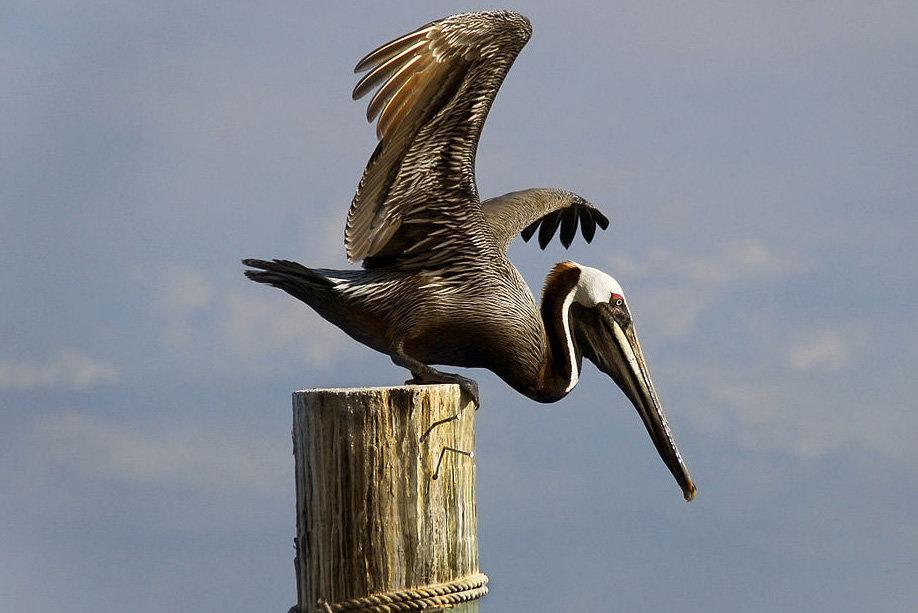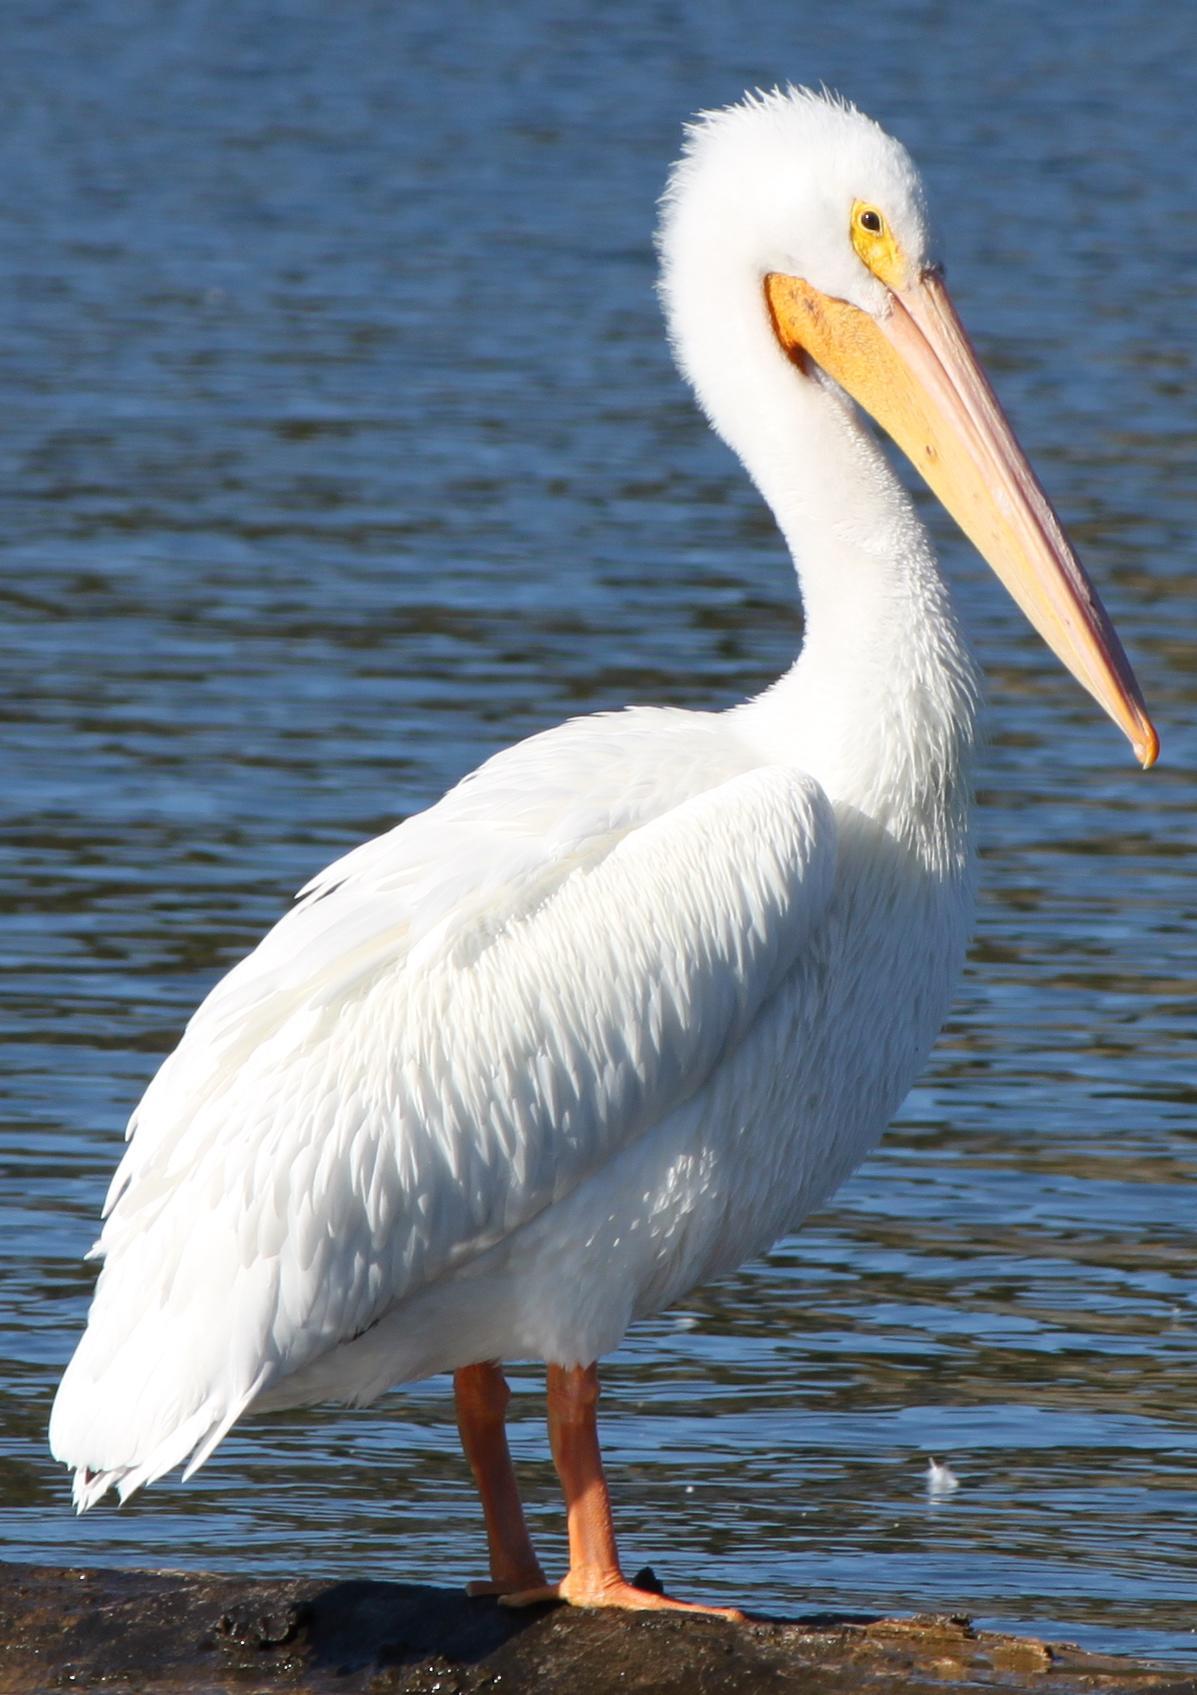The first image is the image on the left, the second image is the image on the right. Evaluate the accuracy of this statement regarding the images: "There is one flying bird.". Is it true? Answer yes or no. No. 